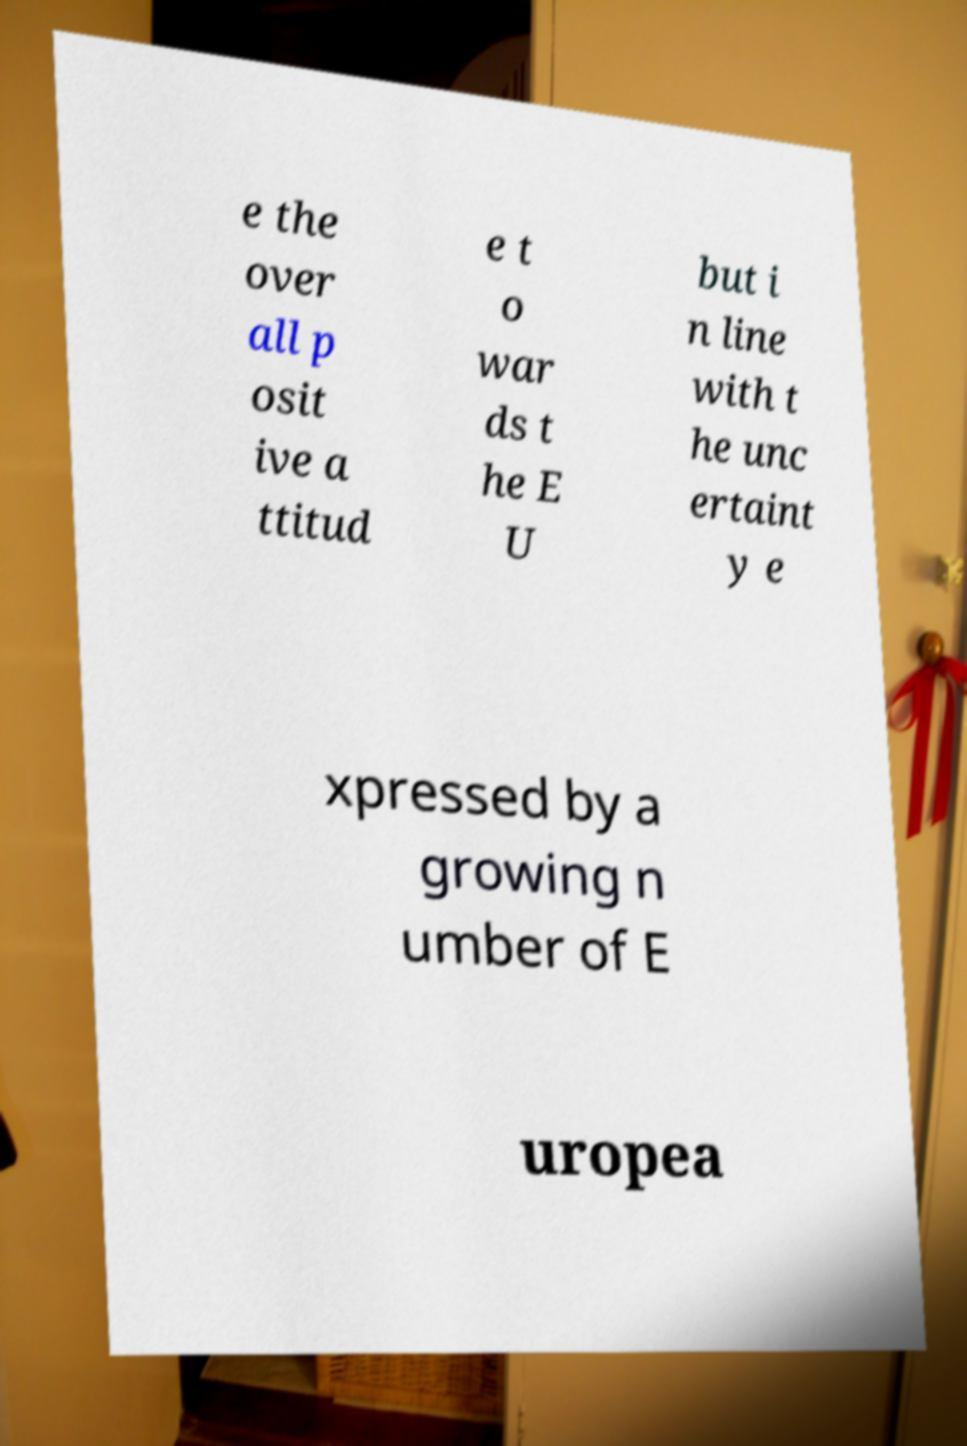I need the written content from this picture converted into text. Can you do that? e the over all p osit ive a ttitud e t o war ds t he E U but i n line with t he unc ertaint y e xpressed by a growing n umber of E uropea 